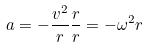Convert formula to latex. <formula><loc_0><loc_0><loc_500><loc_500>a = - \frac { v ^ { 2 } } { r } \frac { r } { r } = - \omega ^ { 2 } r</formula> 